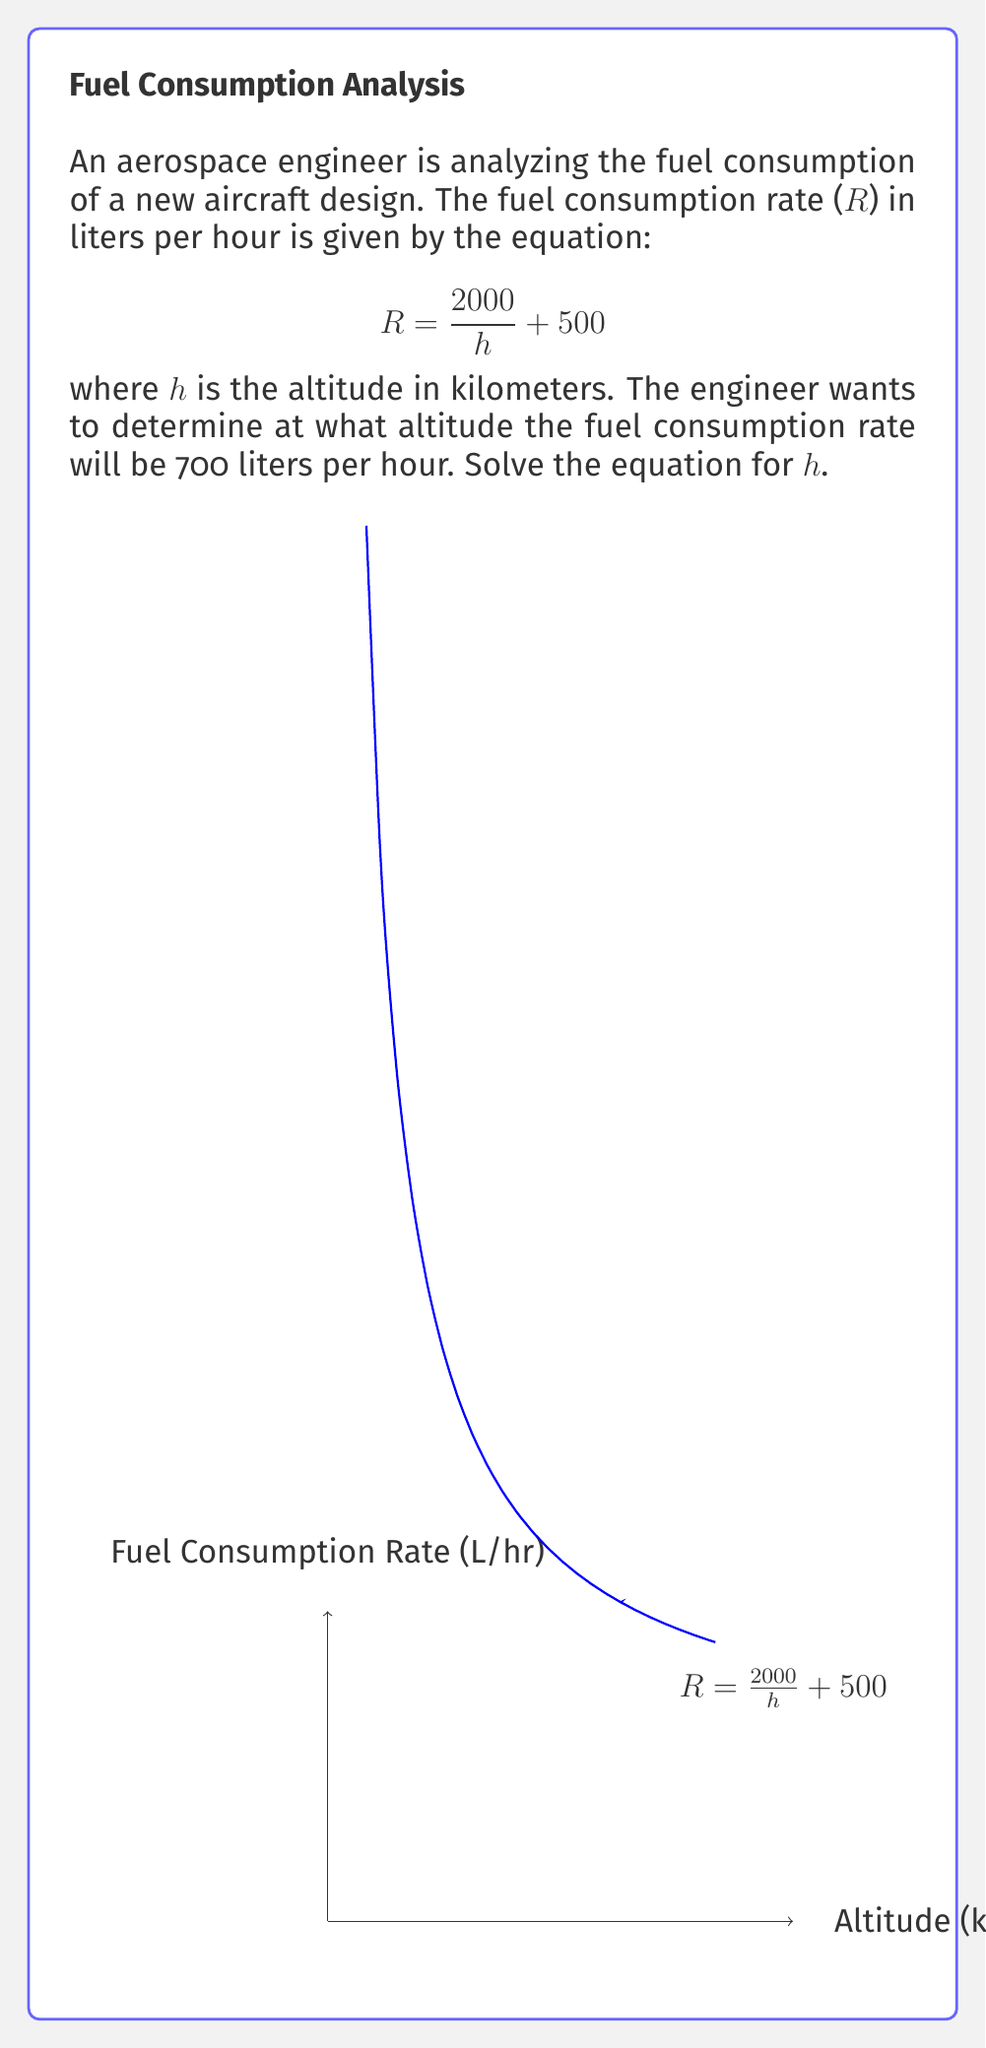Provide a solution to this math problem. Let's solve this step-by-step:

1) We start with the equation:
   $$R = \frac{2000}{h} + 500$$

2) We want to find h when R = 700, so let's substitute this:
   $$700 = \frac{2000}{h} + 500$$

3) Subtract 500 from both sides:
   $$200 = \frac{2000}{h}$$

4) Multiply both sides by h:
   $$200h = 2000$$

5) Divide both sides by 200:
   $$h = \frac{2000}{200} = 10$$

Therefore, the fuel consumption rate will be 700 liters per hour when the altitude is 10 kilometers.

Let's verify:
$$R = \frac{2000}{10} + 500 = 200 + 500 = 700$$

This confirms our solution.
Answer: $h = 10$ km 